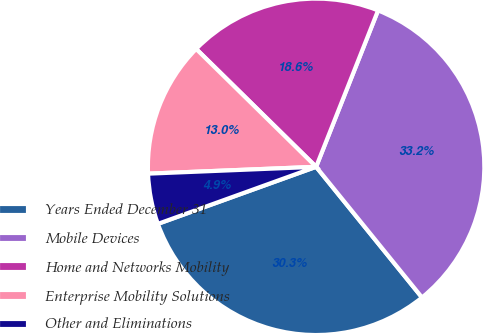Convert chart. <chart><loc_0><loc_0><loc_500><loc_500><pie_chart><fcel>Years Ended December 31<fcel>Mobile Devices<fcel>Home and Networks Mobility<fcel>Enterprise Mobility Solutions<fcel>Other and Eliminations<nl><fcel>30.33%<fcel>33.16%<fcel>18.64%<fcel>13.01%<fcel>4.86%<nl></chart> 